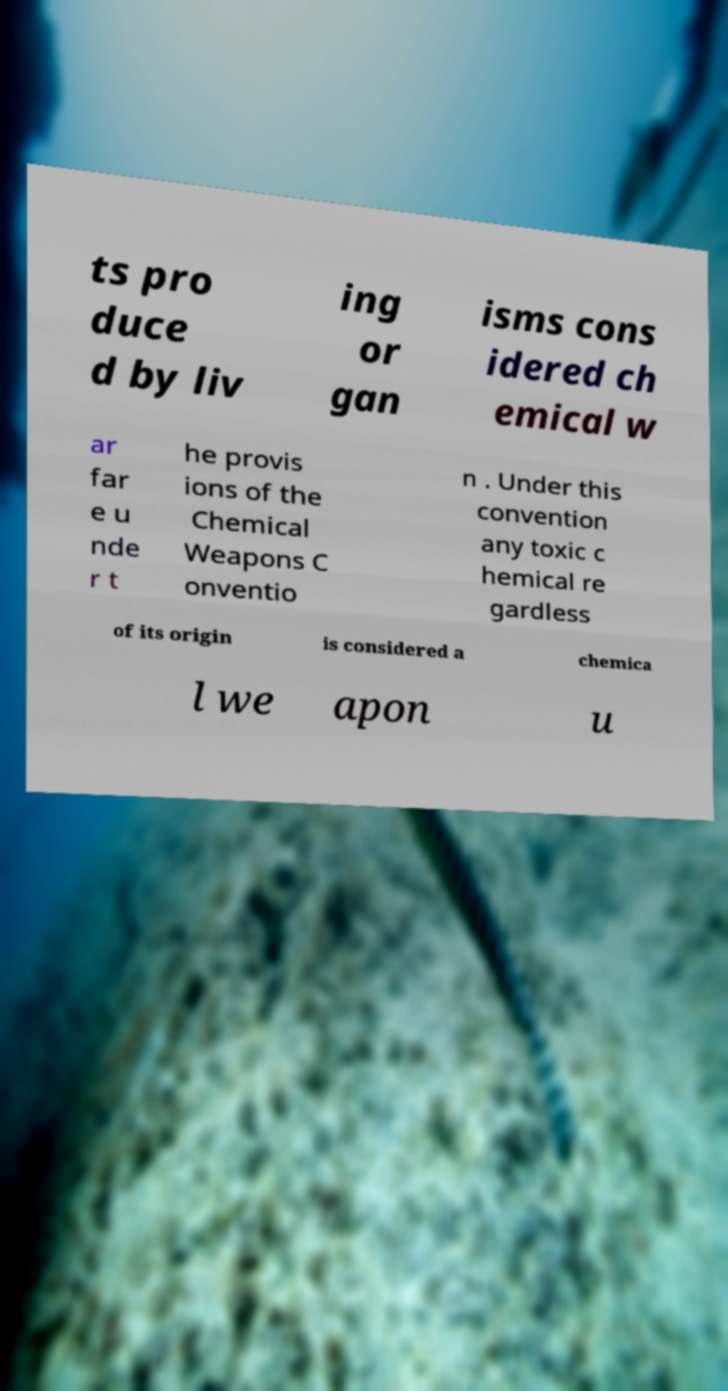Please identify and transcribe the text found in this image. ts pro duce d by liv ing or gan isms cons idered ch emical w ar far e u nde r t he provis ions of the Chemical Weapons C onventio n . Under this convention any toxic c hemical re gardless of its origin is considered a chemica l we apon u 